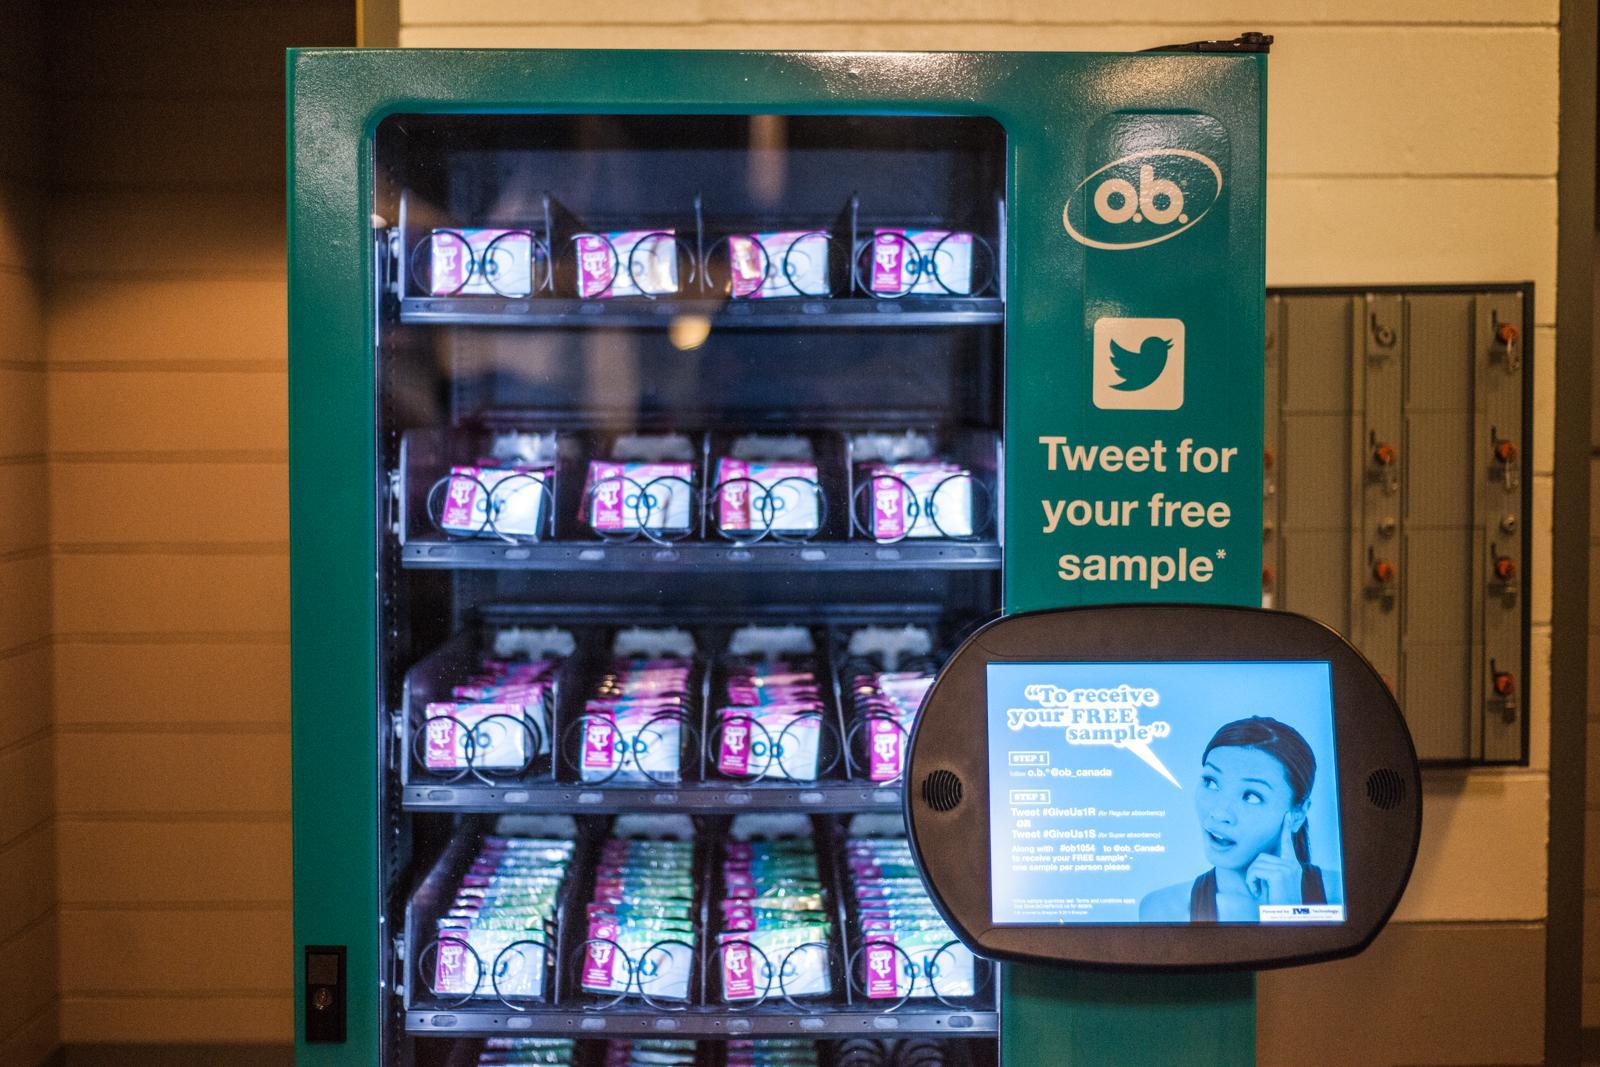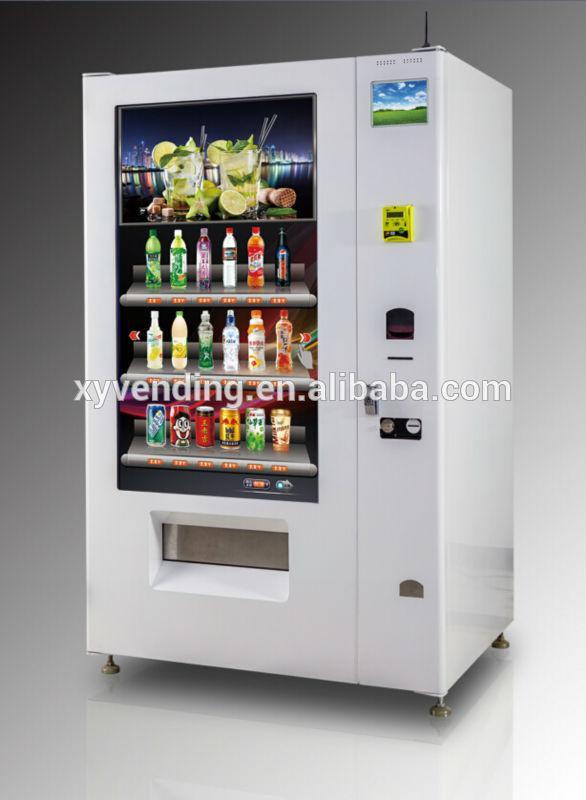The first image is the image on the left, the second image is the image on the right. For the images displayed, is the sentence "There are multiple vending machines, none of which are in restrooms, and there are no people." factually correct? Answer yes or no. Yes. The first image is the image on the left, the second image is the image on the right. Analyze the images presented: Is the assertion "Right image includes a white vending machine that dispenses beverages." valid? Answer yes or no. Yes. 